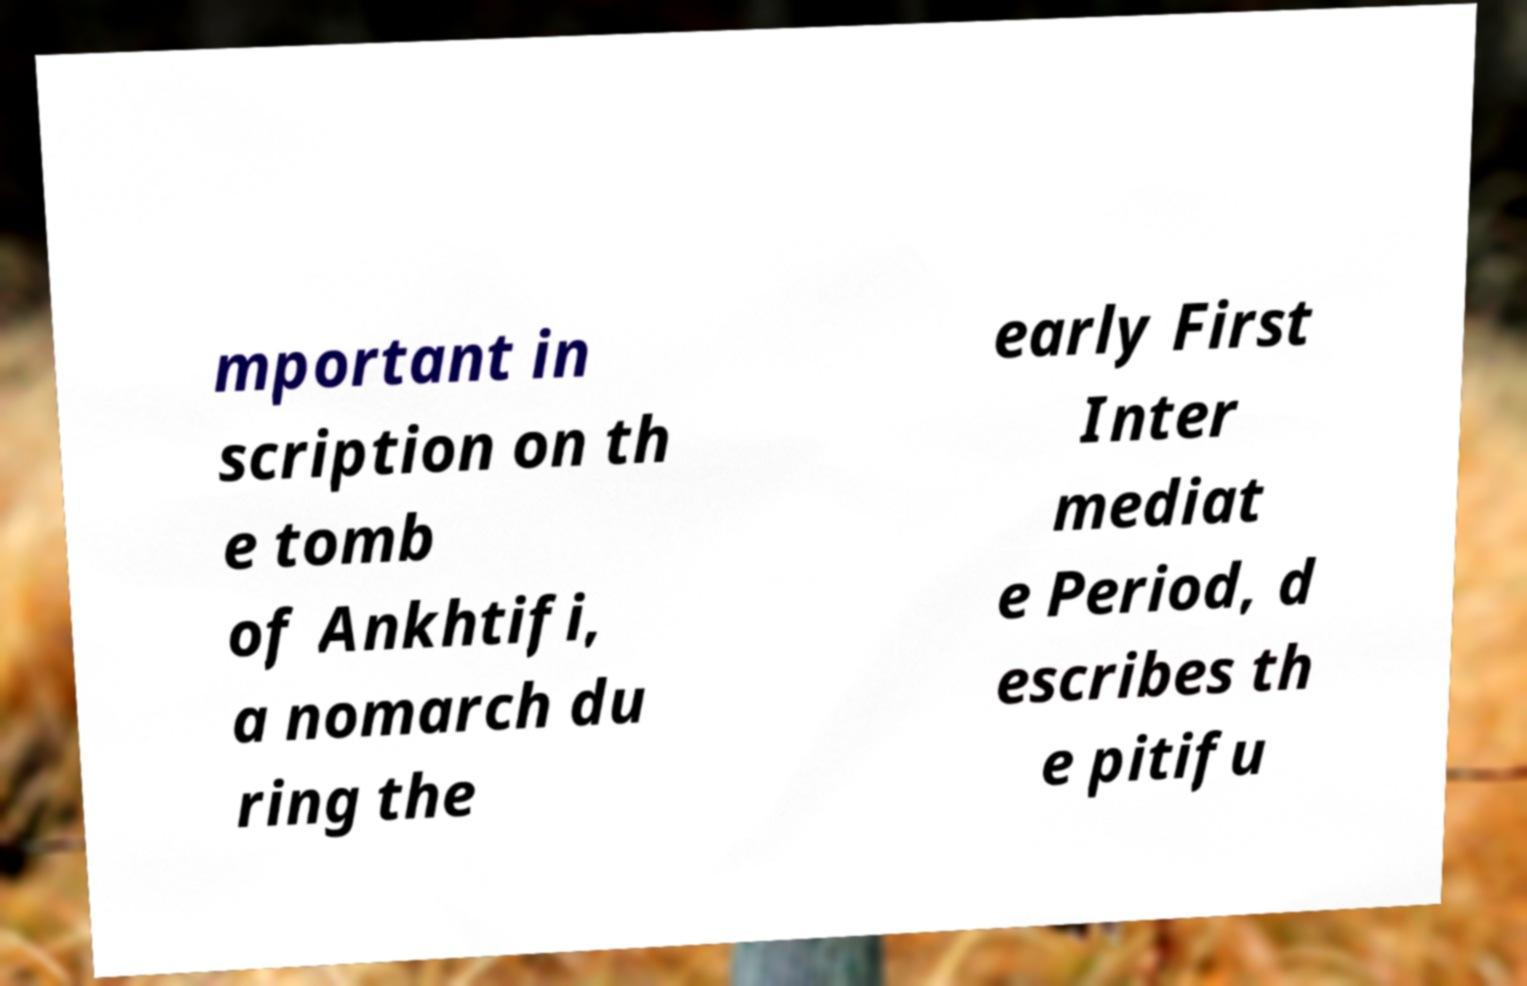There's text embedded in this image that I need extracted. Can you transcribe it verbatim? mportant in scription on th e tomb of Ankhtifi, a nomarch du ring the early First Inter mediat e Period, d escribes th e pitifu 